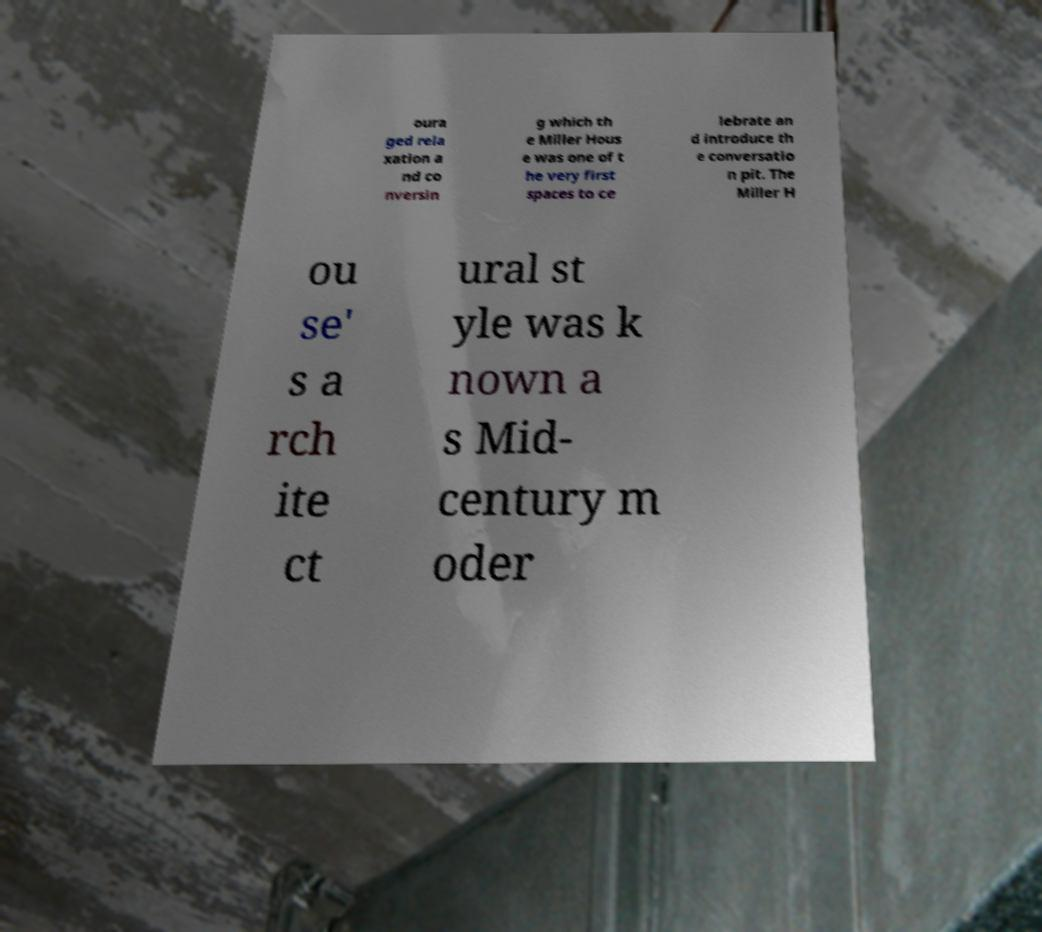Please identify and transcribe the text found in this image. oura ged rela xation a nd co nversin g which th e Miller Hous e was one of t he very first spaces to ce lebrate an d introduce th e conversatio n pit. The Miller H ou se' s a rch ite ct ural st yle was k nown a s Mid- century m oder 